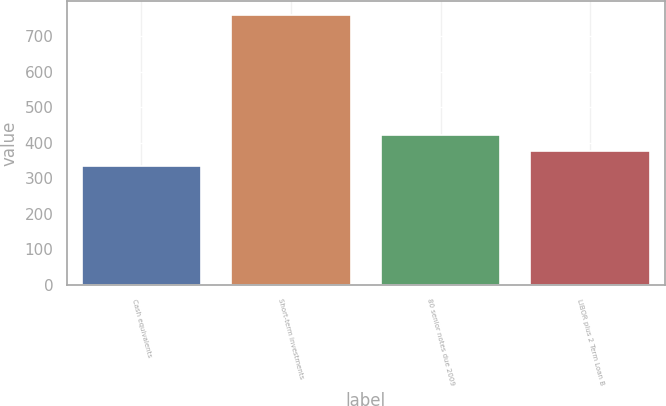Convert chart. <chart><loc_0><loc_0><loc_500><loc_500><bar_chart><fcel>Cash equivalents<fcel>Short-term investments<fcel>80 senior notes due 2009<fcel>LIBOR plus 2 Term Loan B<nl><fcel>336<fcel>761<fcel>421<fcel>378.5<nl></chart> 